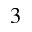<formula> <loc_0><loc_0><loc_500><loc_500>3</formula> 